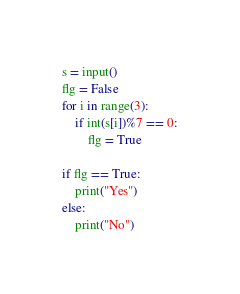<code> <loc_0><loc_0><loc_500><loc_500><_Python_>s = input()
flg = False
for i in range(3):
    if int(s[i])%7 == 0:
        flg = True

if flg == True:
    print("Yes")
else:
    print("No")</code> 